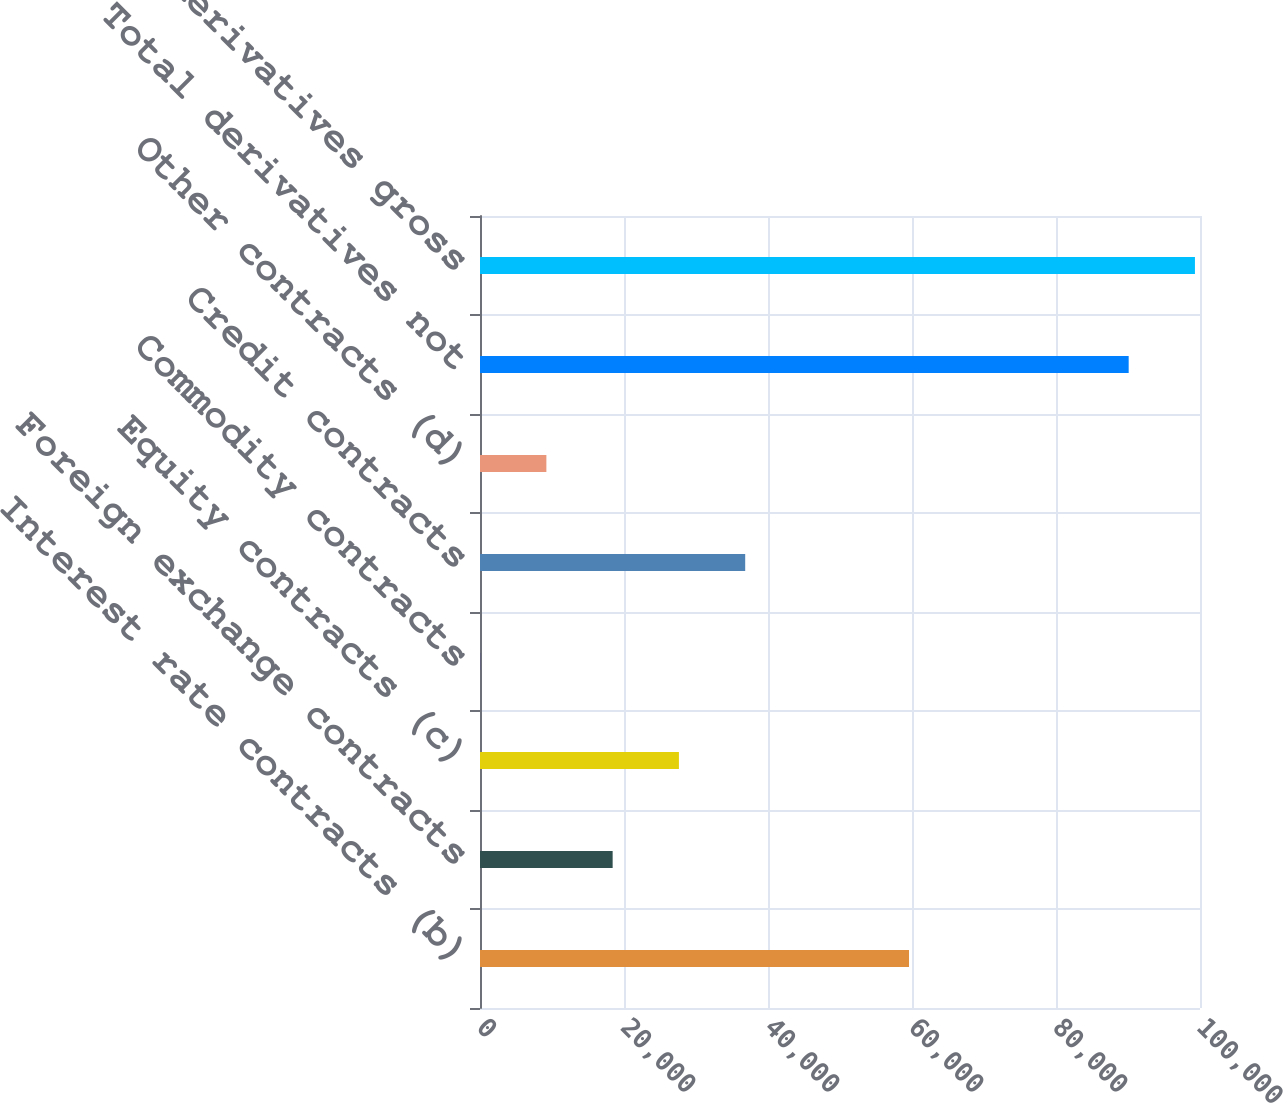<chart> <loc_0><loc_0><loc_500><loc_500><bar_chart><fcel>Interest rate contracts (b)<fcel>Foreign exchange contracts<fcel>Equity contracts (c)<fcel>Commodity contracts<fcel>Credit contracts<fcel>Other contracts (d)<fcel>Total derivatives not<fcel>Total derivatives gross<nl><fcel>59585<fcel>18423<fcel>27628<fcel>13<fcel>36833<fcel>9218<fcel>90094<fcel>99299<nl></chart> 